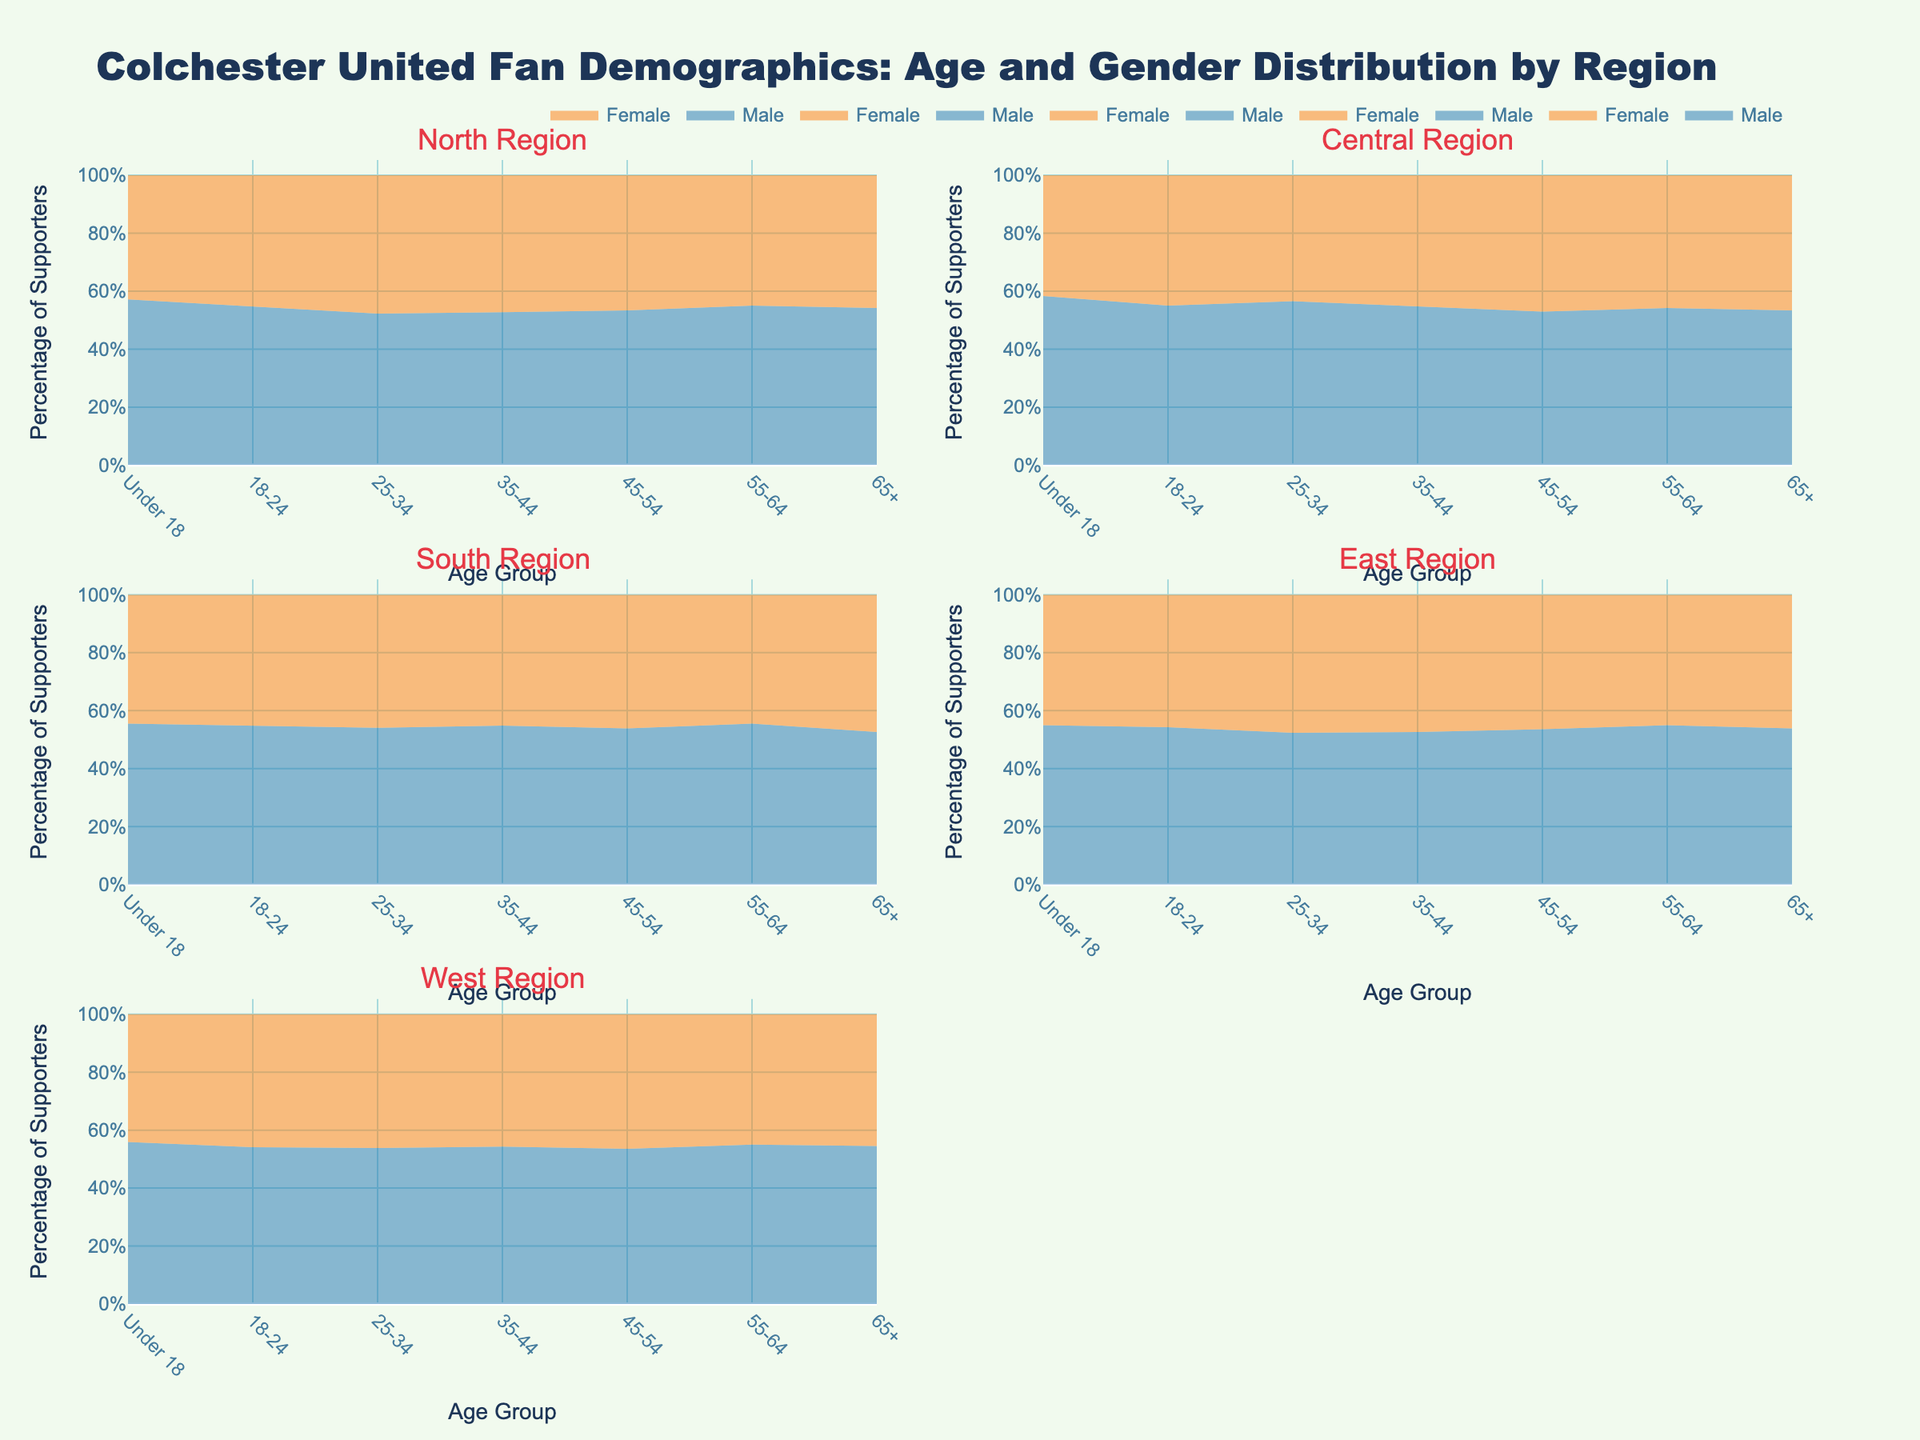What is the title of the plot? The title of the plot is displayed at the top of the figure. It reads, "Colchester United Fan Demographics: Age and Gender Distribution by Region."
Answer: Colchester United Fan Demographics: Age and Gender Distribution by Region What is the age group with the highest percentage of male supporters in the North Region? Observe the subplot for the North Region and look at the curve for male supporters. The highest percentage is in the 25-34 age group.
Answer: 25-34 Which region has the highest percentage of female supporters in the 18-24 age group? Compare the percentage of female supporters in the 18-24 age group across all regions. The Central Region shows the highest percentage.
Answer: Central Region What is the percentage of male supporters aged 55-64 in the East Region? Locate the 55-64 age group in the East Region subplot and observe the male supporters' percentage. It's approximately 15%.
Answer: 15% Which gender has a higher percentage of supporters in the 65+ age group in the South Region? Inspect the South Region subplot for the 65+ age group, comparing the male and female percentages. Males have a higher percentage of supporters.
Answer: Male In which region do the 25-34 age group females have the lowest percentage of supporters? Compare the percentage for females aged 25-34 across all regions. The South Region has the lowest percentage for this group.
Answer: South Region How does the percentage of male and female supporters compare in the Central Region for the 35-44 age group? In the Central Region subplot, observe the percentages for male and female supporters in the 35-44 age group. Males have a higher percentage than females.
Answer: Males higher than females What is the percentage difference between male and female supporters aged 45-54 in the West Region? In the West Region subplot, find the percentages for both genders in the 45-54 age group and calculate the difference. Males are at 20%, and females are at 18%, so the difference is 2%.
Answer: 2% Which age group has the closest percentage of male and female supporters in the East Region? In the East Region subplot, compare the male and female percentages for each age group. The 18-24 age group has the closest percentages.
Answer: 18-24 